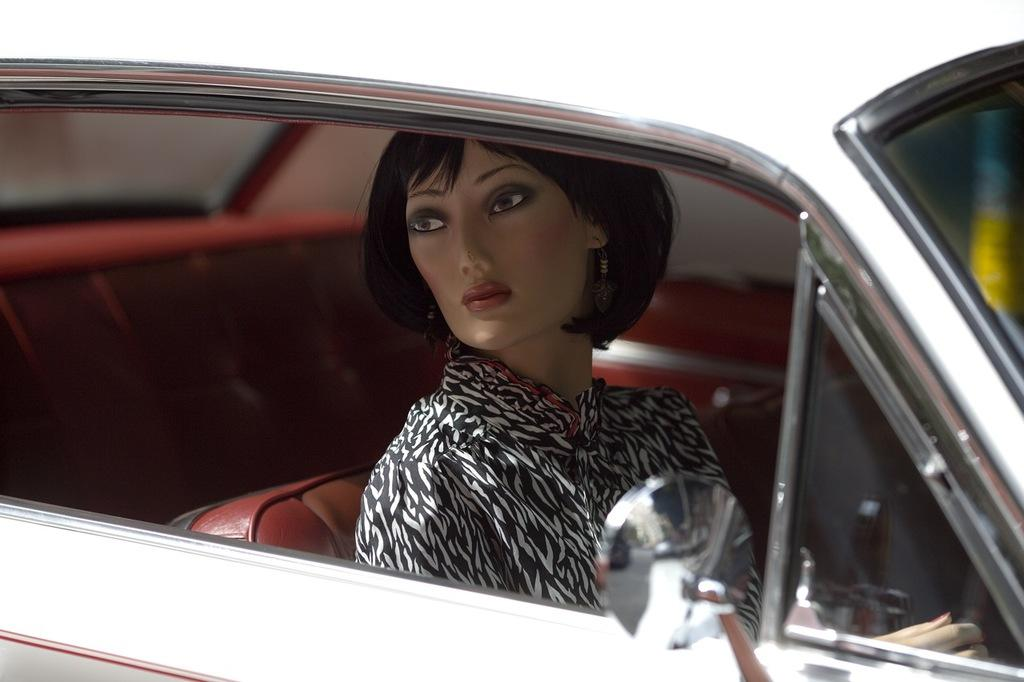What is the main subject of the image? There is a car in the image. Who is inside the car? A woman is sitting inside the car. What is the woman doing in the image? The woman is looking at something. How can you tell that the image is likely graphical in nature? The description suggests that the image is not a photograph, but rather a drawing or illustration. What type of bomb can be seen in the image? There is no bomb present in the image; it features a car with a woman inside. What kind of show is the woman attending in the image? There is no indication of a show or any event in the image; it simply shows a woman sitting in a car. 